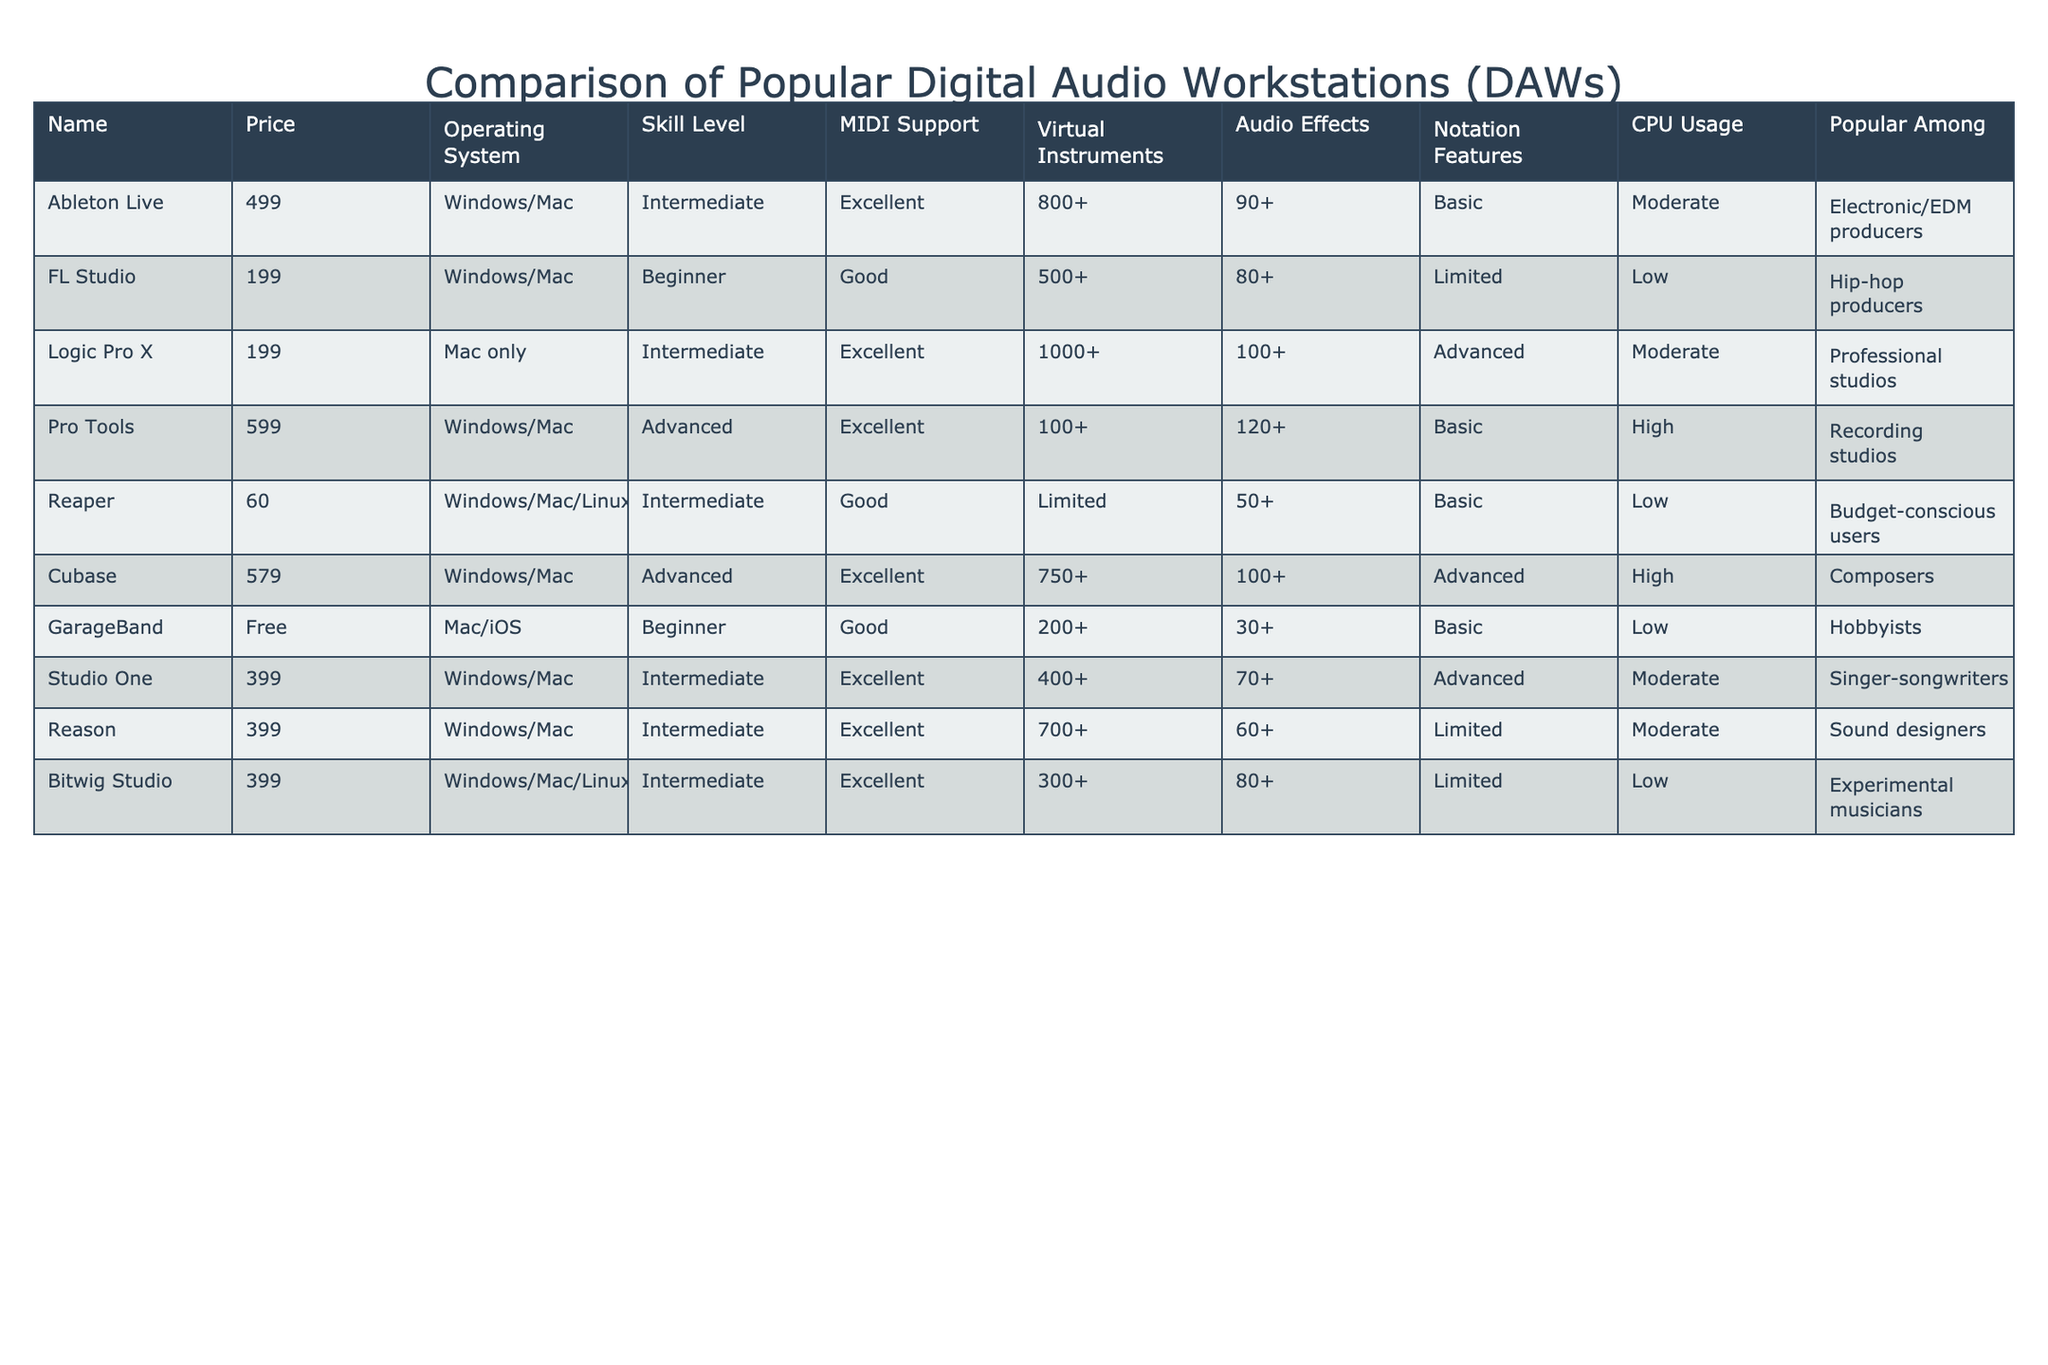What is the price of Logic Pro X? The price of Logic Pro X is listed in the table under the "Price" column. It is indicated as 199.
Answer: 199 Which DAW has the highest CPU usage? The "CPU Usage" column shows the values for each DAW. By comparing these values, Pro Tools has the highest CPU usage, listed as High.
Answer: Pro Tools Is GarageBand available for Windows? Checking the "Operating System" column for GarageBand shows that it is only available for Mac/iOS, indicating it is not available for Windows.
Answer: No What is the total number of virtual instruments supported by the DAWs that are classified as Advanced skill level? The "Virtual Instruments" column includes the following for Advanced DAWs: Pro Tools (100), Cubase (750). Adding these gives: 100 + 750 = 850.
Answer: 850 Which DAW is popular among budget-conscious users? The "Popular Among" column indicates that Reaper is listed under budget-conscious users. This can be found directly without further calculations.
Answer: Reaper How many DAWs have excellent MIDI support? By filtering the "MIDI Support" column for "Excellent," we identify Ableton Live, Logic Pro X, Pro Tools, Cubase, Reason, and so on. Counting these gives a total of 5 DAWs.
Answer: 5 What is the difference in price between the most expensive and least expensive DAWs? The most expensive DAW is Pro Tools at 599, and the least expensive is Reaper at 60. The difference is calculated by subtracting 60 from 599: 599 - 60 = 539.
Answer: 539 Which DAW supports the most audio effects? The "Audio Effects" column shows the values: Pro Tools (120+), Logic Pro X (100+), Cubase (100+), others have lower values. Comparing these, Pro Tools supports the most audio effects with 120+.
Answer: Pro Tools How many DAWs are free for users? Scanning the "Price" column, only GarageBand is marked as Free. This means there's just 1 DAW that has no cost.
Answer: 1 